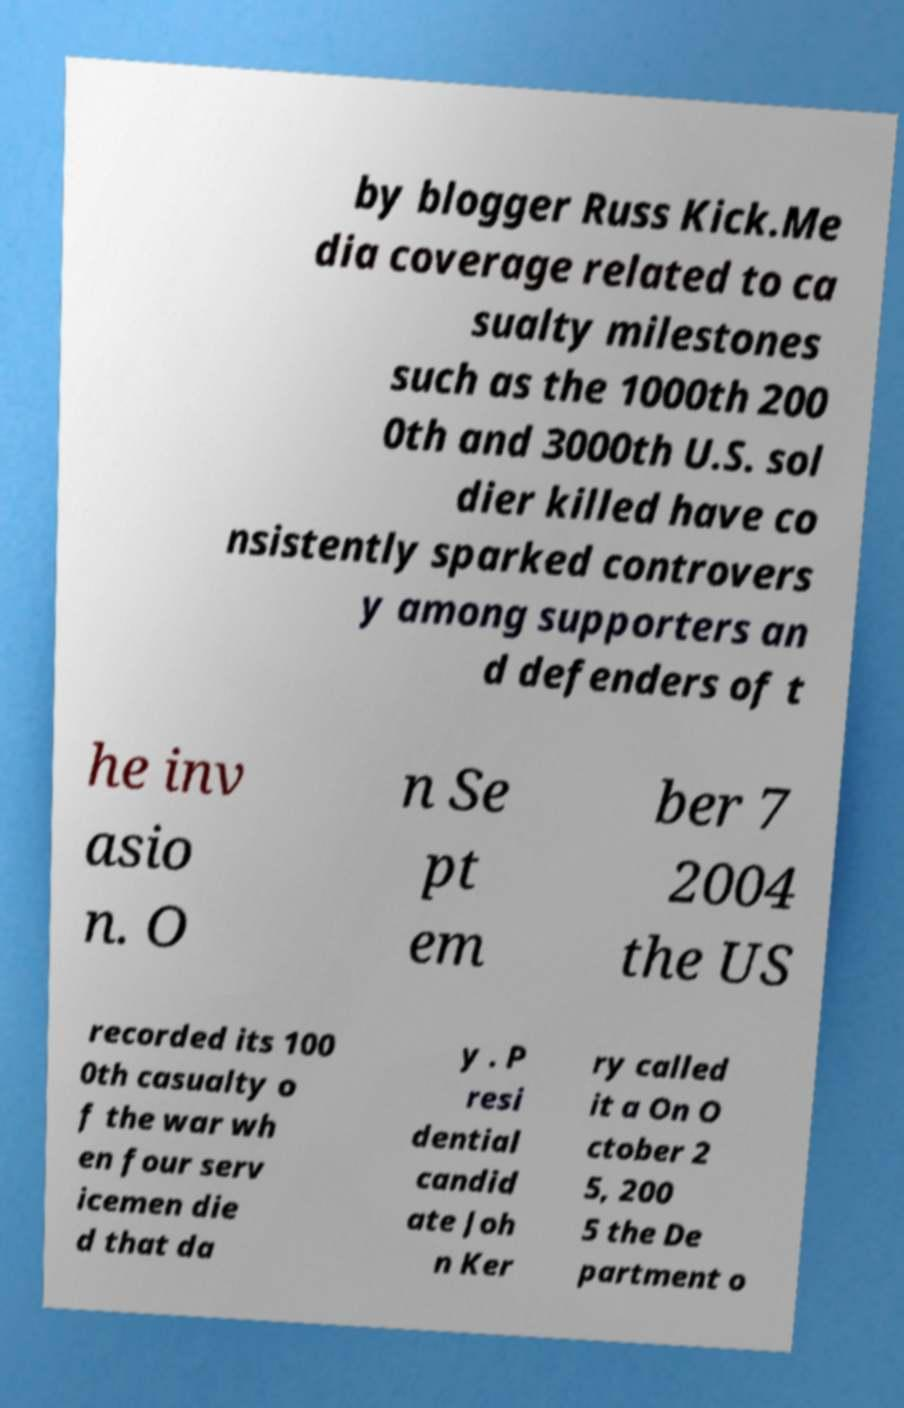Please read and relay the text visible in this image. What does it say? by blogger Russ Kick.Me dia coverage related to ca sualty milestones such as the 1000th 200 0th and 3000th U.S. sol dier killed have co nsistently sparked controvers y among supporters an d defenders of t he inv asio n. O n Se pt em ber 7 2004 the US recorded its 100 0th casualty o f the war wh en four serv icemen die d that da y . P resi dential candid ate Joh n Ker ry called it a On O ctober 2 5, 200 5 the De partment o 